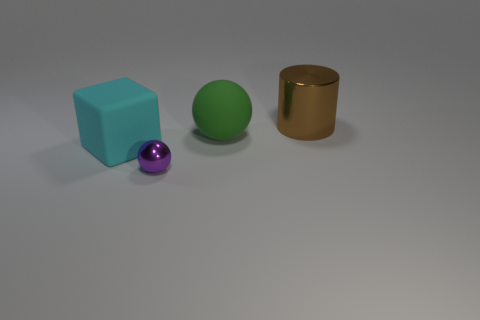Add 1 large objects. How many objects exist? 5 Subtract 2 spheres. How many spheres are left? 0 Subtract all red cylinders. Subtract all blue cubes. How many cylinders are left? 1 Subtract all green cubes. How many purple cylinders are left? 0 Subtract all large cyan objects. Subtract all large brown shiny objects. How many objects are left? 2 Add 3 green matte balls. How many green matte balls are left? 4 Add 1 brown metal things. How many brown metal things exist? 2 Subtract 1 brown cylinders. How many objects are left? 3 